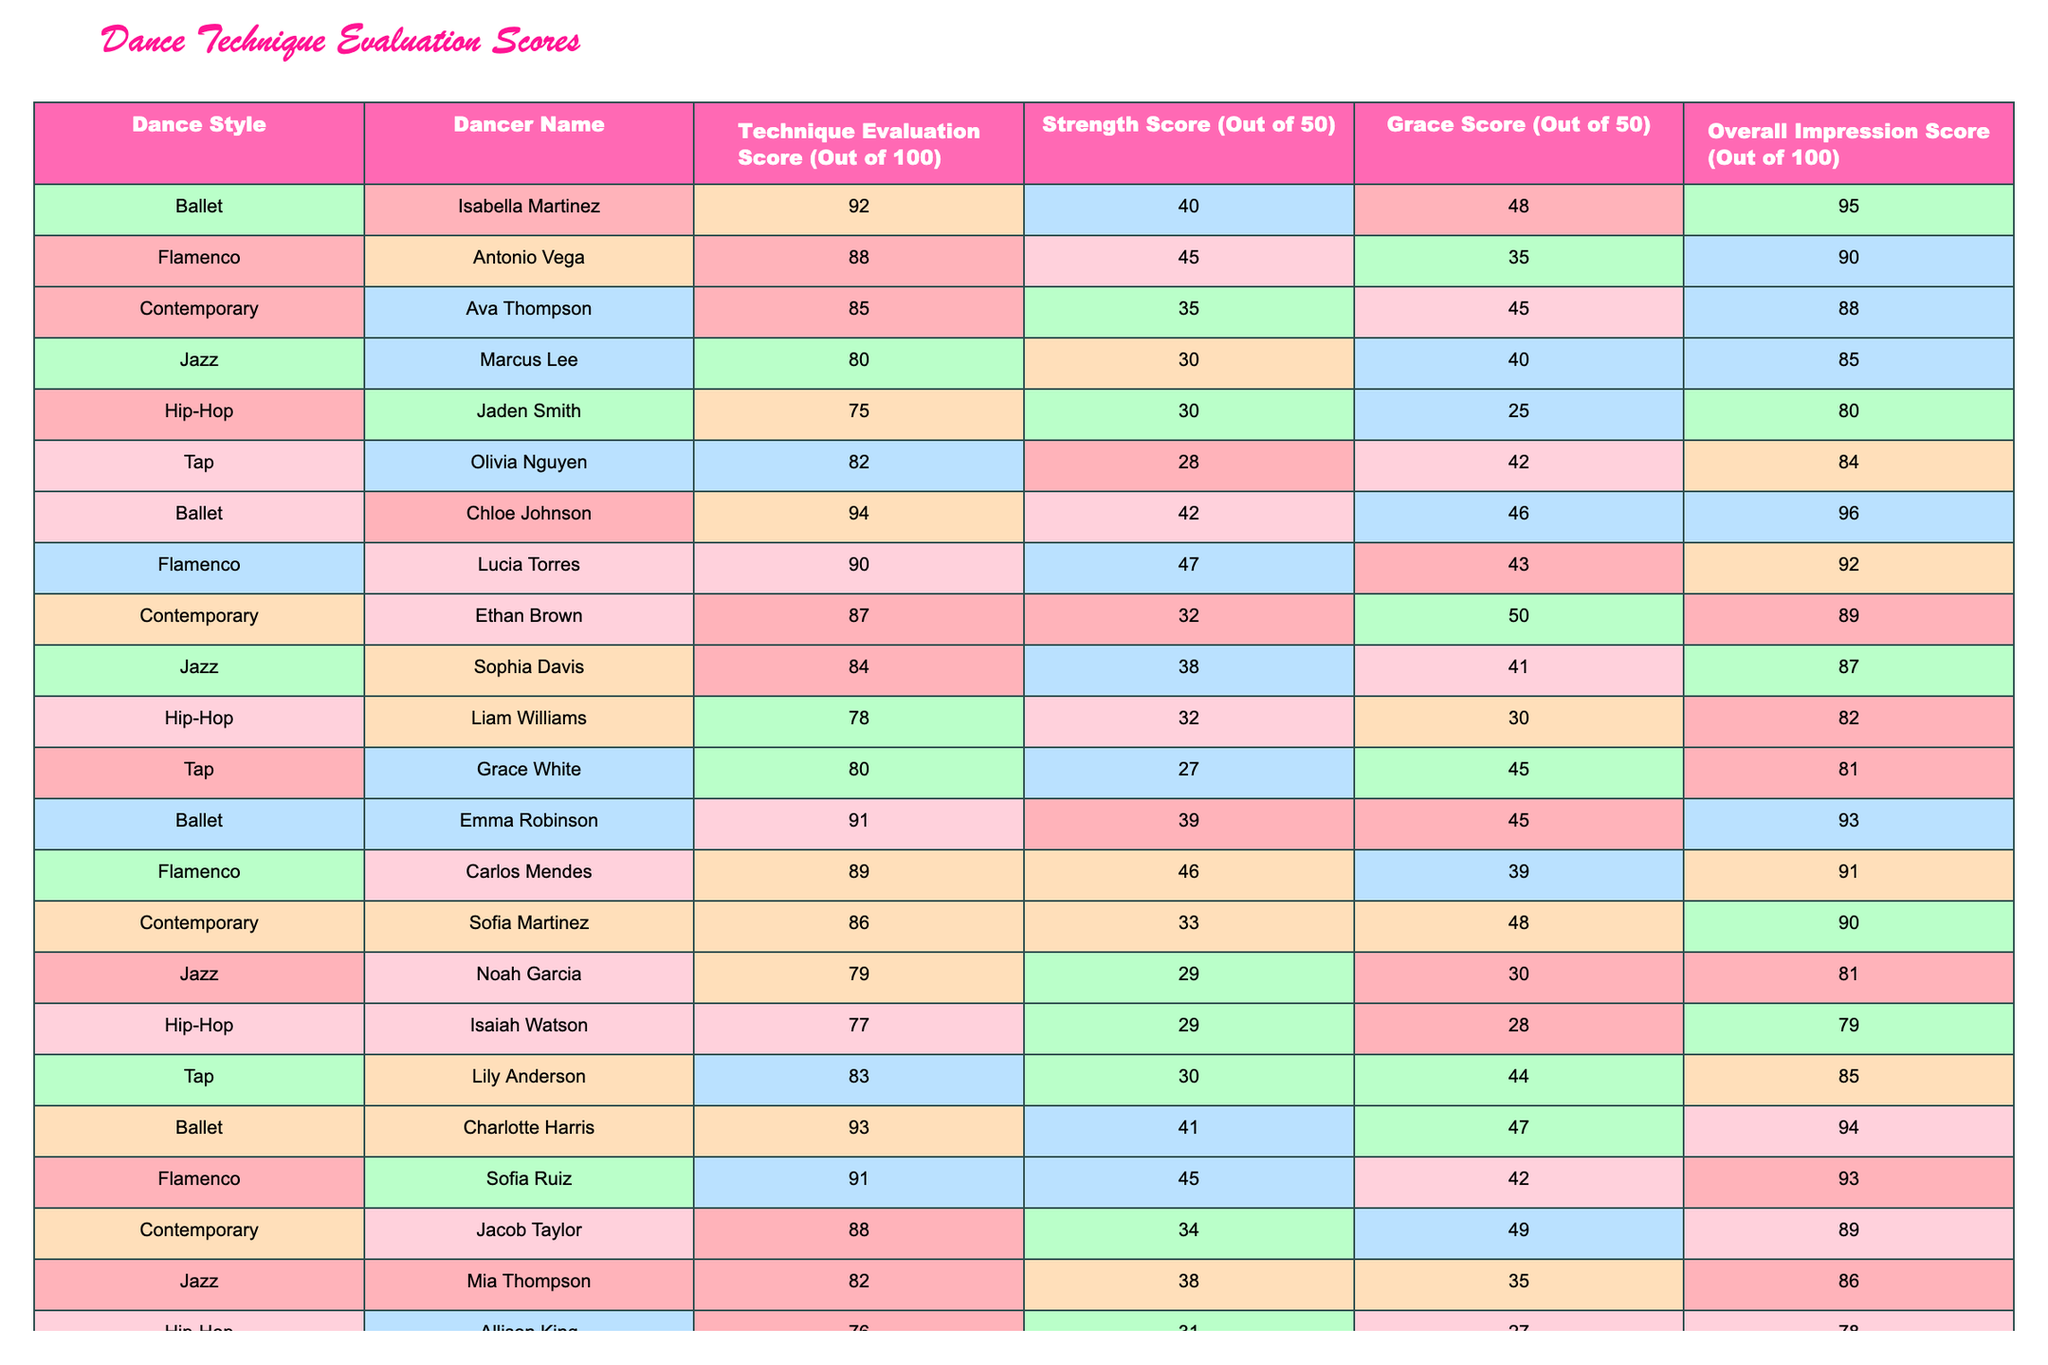What is the highest Technique Evaluation Score among the dancers? By looking at the Technique Evaluation Score column, the highest score is 94, which belongs to Chloe Johnson.
Answer: 94 Who received the lowest overall impression score? In the Overall Impression Score column, the lowest score is 78, which corresponds to Allison King.
Answer: 78 What is the average Strength Score of the Ballet dancers? The Ballet dancers' Strength Scores are 40, 42, 39, and 41. The average is calculated by (40 + 42 + 39 + 41) / 4 = 40.5.
Answer: 40.5 Which Flamenco dancer has the highest Overall Impression Score? I check the Overall Impression Score for the Flamenco dancers: Antonio Vega has 90, Lucia Torres has 92, Carlos Mendes has 91, and Sofia Ruiz has 93. The highest is Sofia Ruiz with 93.
Answer: 93 Is there any dancer who scored exactly 80 in the Technique Evaluation Score? I review the Technique Evaluation Score column and find that Olivia Nguyen scored 82, Jackson Lewis scored 81, and no dancer has exactly 80. Therefore, the answer is no.
Answer: No What is the difference between the highest and lowest Technique Evaluation Scores? The highest is 94 (Chloe Johnson) and the lowest is 75 (Jaden Smith), so the difference is 94 - 75 = 19.
Answer: 19 How many dancers scored an Overall Impression Score above 90? I count the Overall Impression Scores: 95 (Isabella), 90 (Antonio), 92 (Lucia), 91 (Carlos), 93 (Sofia), 93 (Chloe). There are 6 dancers with scores above 90.
Answer: 6 Which style has the highest average Technique Evaluation Score? The average scores for each style are: Ballet (92.5), Flamenco (89.25), Contemporary (86.67), Jazz (81.25), Hip-Hop (76), Tap (81.33). Ballet has the highest average of 92.5.
Answer: Ballet What is the combined score of Grace and Strength for the Contemporary dancers? The Strength Scores for Contemporary dancers are 35, 32, and 33 and the Grace Scores are 45, 50, and 48. Their combined scores are (35 + 45) + (32 + 50) + (33 + 48) = 198.
Answer: 198 Which dancer improved the most in Strength compared to their Grace score? For each dancer, calculate the difference between Strength and Grace scores: Ava Thompson (10), Ethan Brown (-18), and Sofia Martinez (-15). Ava Thompson has the highest difference with +10.
Answer: Ava Thompson 